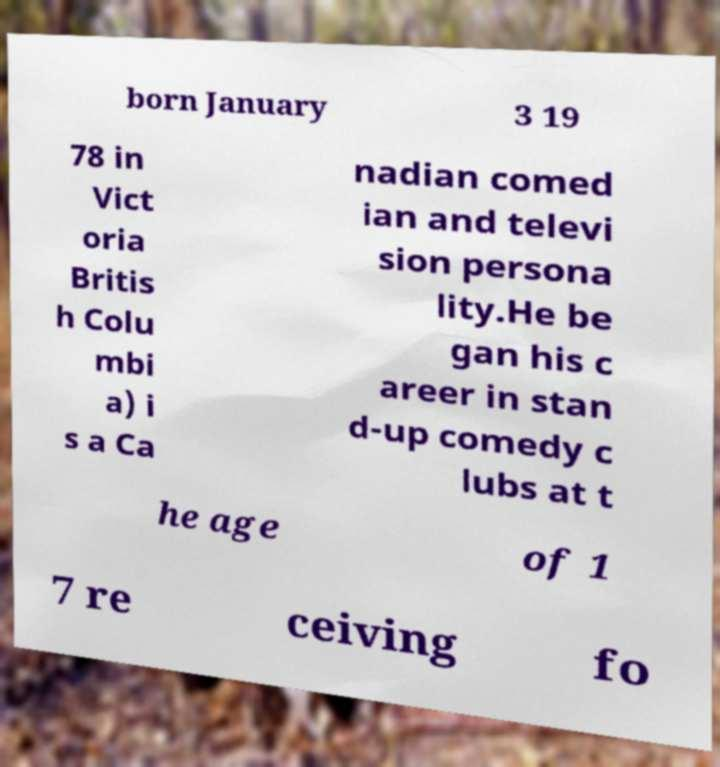Can you accurately transcribe the text from the provided image for me? born January 3 19 78 in Vict oria Britis h Colu mbi a) i s a Ca nadian comed ian and televi sion persona lity.He be gan his c areer in stan d-up comedy c lubs at t he age of 1 7 re ceiving fo 